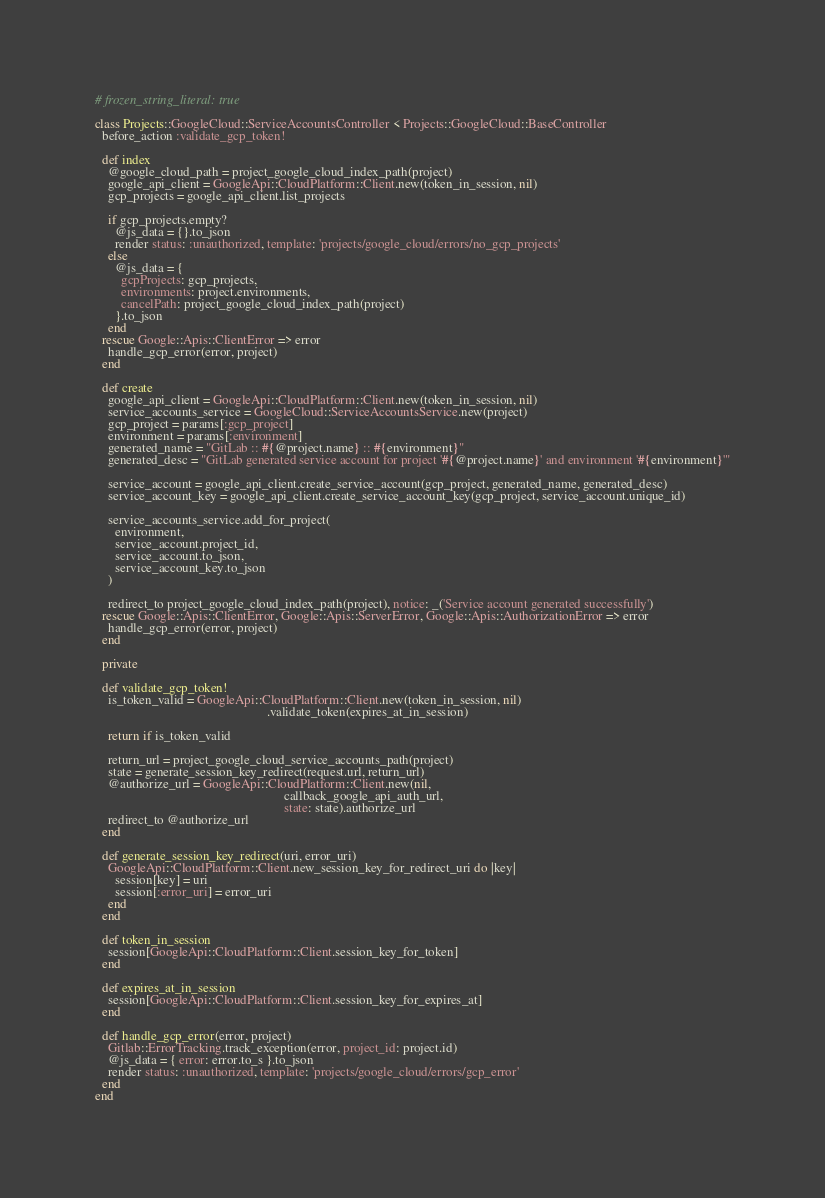Convert code to text. <code><loc_0><loc_0><loc_500><loc_500><_Ruby_># frozen_string_literal: true

class Projects::GoogleCloud::ServiceAccountsController < Projects::GoogleCloud::BaseController
  before_action :validate_gcp_token!

  def index
    @google_cloud_path = project_google_cloud_index_path(project)
    google_api_client = GoogleApi::CloudPlatform::Client.new(token_in_session, nil)
    gcp_projects = google_api_client.list_projects

    if gcp_projects.empty?
      @js_data = {}.to_json
      render status: :unauthorized, template: 'projects/google_cloud/errors/no_gcp_projects'
    else
      @js_data = {
        gcpProjects: gcp_projects,
        environments: project.environments,
        cancelPath: project_google_cloud_index_path(project)
      }.to_json
    end
  rescue Google::Apis::ClientError => error
    handle_gcp_error(error, project)
  end

  def create
    google_api_client = GoogleApi::CloudPlatform::Client.new(token_in_session, nil)
    service_accounts_service = GoogleCloud::ServiceAccountsService.new(project)
    gcp_project = params[:gcp_project]
    environment = params[:environment]
    generated_name = "GitLab :: #{@project.name} :: #{environment}"
    generated_desc = "GitLab generated service account for project '#{@project.name}' and environment '#{environment}'"

    service_account = google_api_client.create_service_account(gcp_project, generated_name, generated_desc)
    service_account_key = google_api_client.create_service_account_key(gcp_project, service_account.unique_id)

    service_accounts_service.add_for_project(
      environment,
      service_account.project_id,
      service_account.to_json,
      service_account_key.to_json
    )

    redirect_to project_google_cloud_index_path(project), notice: _('Service account generated successfully')
  rescue Google::Apis::ClientError, Google::Apis::ServerError, Google::Apis::AuthorizationError => error
    handle_gcp_error(error, project)
  end

  private

  def validate_gcp_token!
    is_token_valid = GoogleApi::CloudPlatform::Client.new(token_in_session, nil)
                                                     .validate_token(expires_at_in_session)

    return if is_token_valid

    return_url = project_google_cloud_service_accounts_path(project)
    state = generate_session_key_redirect(request.url, return_url)
    @authorize_url = GoogleApi::CloudPlatform::Client.new(nil,
                                                          callback_google_api_auth_url,
                                                          state: state).authorize_url
    redirect_to @authorize_url
  end

  def generate_session_key_redirect(uri, error_uri)
    GoogleApi::CloudPlatform::Client.new_session_key_for_redirect_uri do |key|
      session[key] = uri
      session[:error_uri] = error_uri
    end
  end

  def token_in_session
    session[GoogleApi::CloudPlatform::Client.session_key_for_token]
  end

  def expires_at_in_session
    session[GoogleApi::CloudPlatform::Client.session_key_for_expires_at]
  end

  def handle_gcp_error(error, project)
    Gitlab::ErrorTracking.track_exception(error, project_id: project.id)
    @js_data = { error: error.to_s }.to_json
    render status: :unauthorized, template: 'projects/google_cloud/errors/gcp_error'
  end
end
</code> 